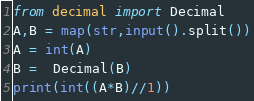<code> <loc_0><loc_0><loc_500><loc_500><_Python_>from decimal import Decimal
A,B = map(str,input().split())
A = int(A)
B =  Decimal(B)
print(int((A*B)//1))</code> 